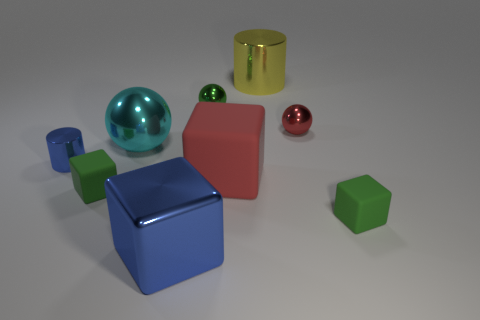Is the number of cubes that are on the left side of the big blue metal block greater than the number of purple metal spheres? The number of cubes to the left of the big blue block is two, which exactly matches the count of purple metal spheres present, therefore, the number of cubes is not greater than the number of purple spheres. 